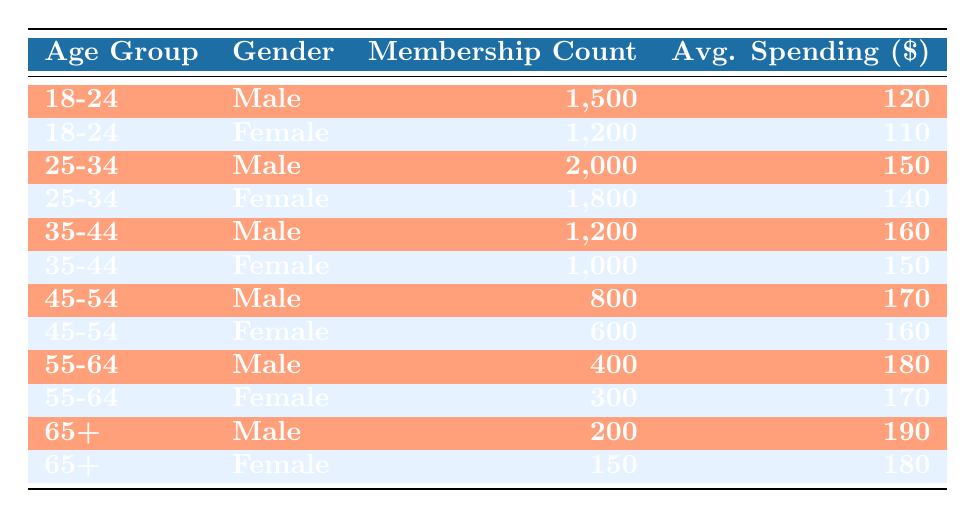What is the membership count for the 25-34 age group, male? The table shows that the membership count for males in the 25-34 age group is listed directly under the respective row. In that row, the value is 2000.
Answer: 2000 What is the average spending of female members in the 35-44 age group? Looking at the row for females in the 35-44 age group, the average spending is noted in the corresponding column. The value provided is 150.
Answer: 150 True or False: The average spending for female members in the 18-24 age group is higher than that of male members in the same age group. For females in the 18-24 age group, the average spending is 110, while for males it is 120. Since 110 is not higher than 120, the statement is false.
Answer: False What is the total membership count for the 45-54 age group? To find the total membership count for the 45-54 age group, we need to add the counts for both genders: 800 (male) + 600 (female) = 1400.
Answer: 1400 How much more do male members in the 65+ age group spend on average than female members in the same age group? First, we look at the average spending for both genders in the 65+ age group. Males spend 190 and females spend 180. The difference is 190 - 180 = 10.
Answer: 10 What is the average age group spending for all male members? We will calculate the average for male members by summing their spending across all age groups (120 + 150 + 160 + 170 + 180 + 190) and dividing by the number of age groups (6): (120 + 150 + 160 + 170 + 180 + 190) = 1070; 1070/6 = 178.33. Thus, rounding gives 178.
Answer: 178 Is the membership count for females in the 18-24 age group higher than for females in the 45-54 age group? We compare the membership counts: 1200 (females in 18-24) and 600 (females in 45-54). Since 1200 is greater than 600, the statement is true.
Answer: True What is the total average spending of all male members? We will sum the average spending for male members across all age groups (120 + 150 + 160 + 170 + 180 + 190) = 1070, then divide by the number of data points (6): 1070 / 6 = 178.33, rounded gives 178.
Answer: 178 Which age group has the lowest female membership count? To find this, we inspect the membership counts for females across all age groups: 1200, 1800, 1000, 600, 300, 150. The lowest value is 150 in the 65+ age group.
Answer: 65+ 